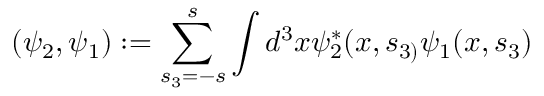Convert formula to latex. <formula><loc_0><loc_0><loc_500><loc_500>( \psi _ { 2 } , \psi _ { 1 } ) \colon = \sum _ { s _ { 3 } = - s } ^ { s } \int d ^ { 3 } x \psi _ { 2 } ^ { * } ( x , s _ { 3 ) } \psi _ { 1 } ( x , s _ { 3 } )</formula> 